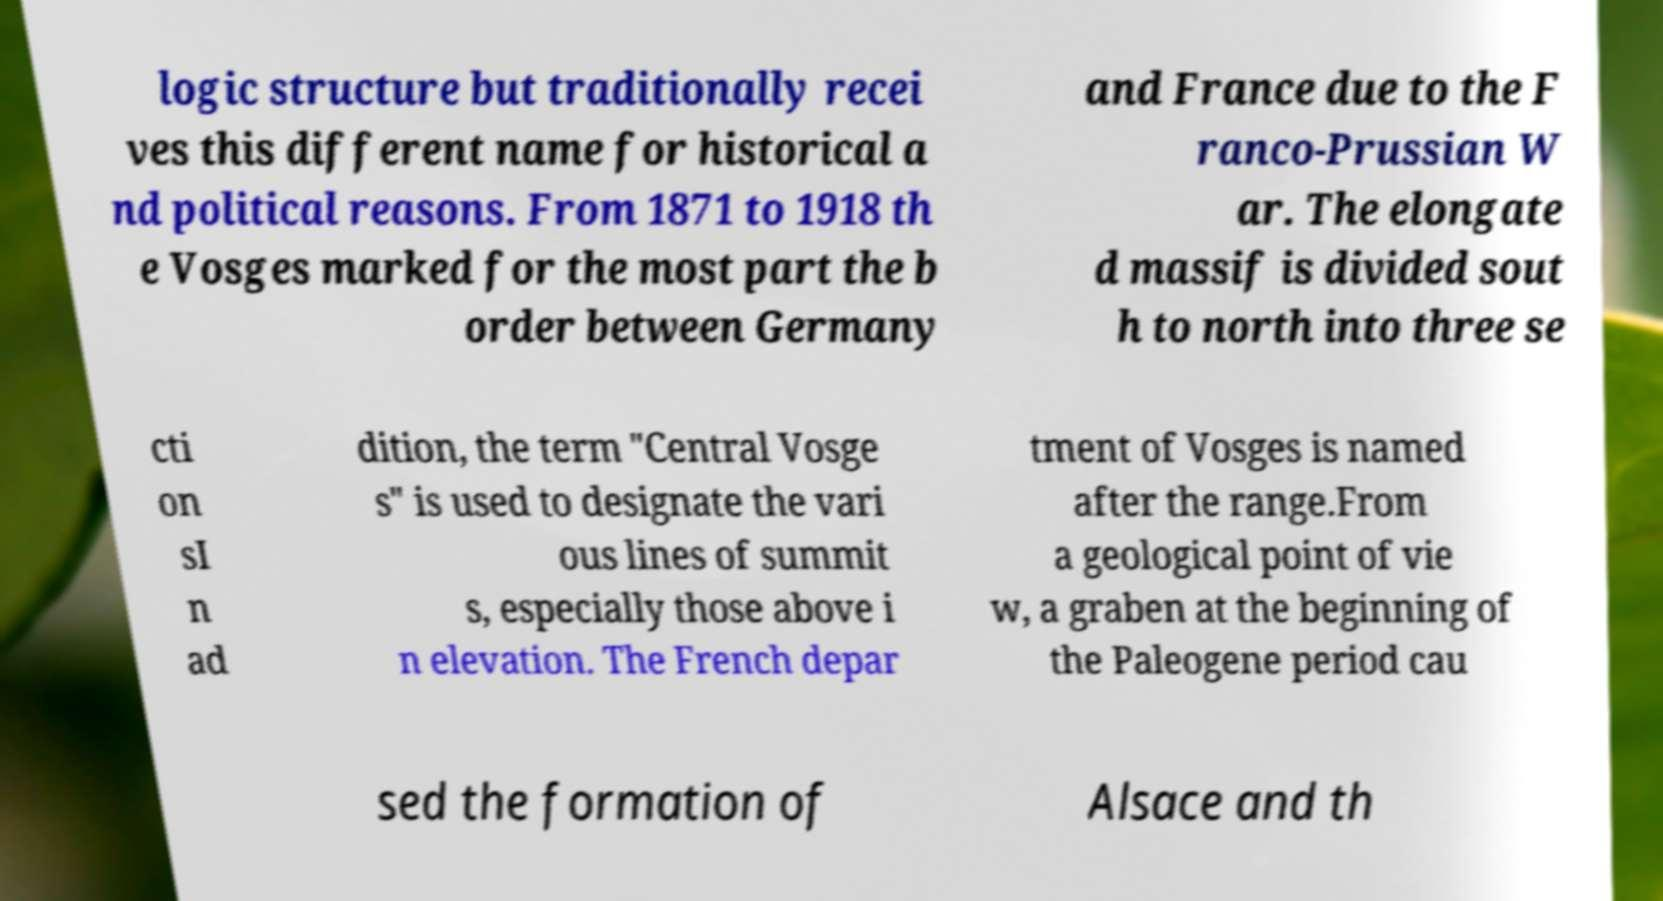For documentation purposes, I need the text within this image transcribed. Could you provide that? logic structure but traditionally recei ves this different name for historical a nd political reasons. From 1871 to 1918 th e Vosges marked for the most part the b order between Germany and France due to the F ranco-Prussian W ar. The elongate d massif is divided sout h to north into three se cti on sI n ad dition, the term "Central Vosge s" is used to designate the vari ous lines of summit s, especially those above i n elevation. The French depar tment of Vosges is named after the range.From a geological point of vie w, a graben at the beginning of the Paleogene period cau sed the formation of Alsace and th 